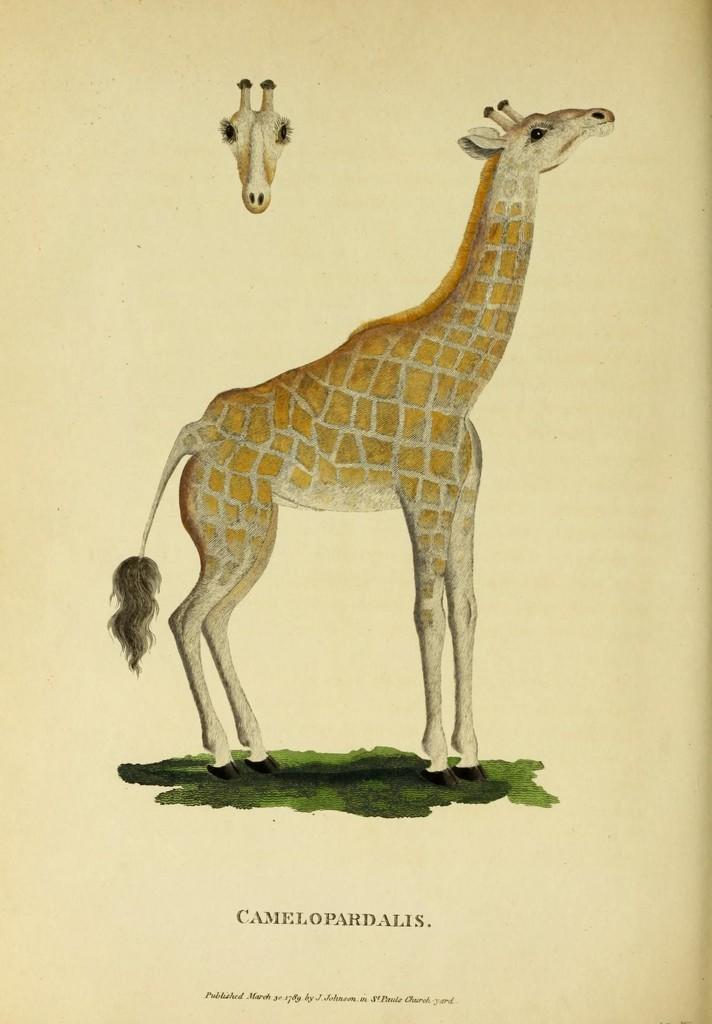What is the main subject of the painting in the image? The main subject of the painting in the image is a giraffe. What can be found at the bottom of the painting? There is text at the bottom of the painting. Where is the head of the giraffe located in the painting? The head of the giraffe is visible at the top of the painting. What color is the heart-shaped stick balloon in the image? There is no heart-shaped stick balloon present in the image. 